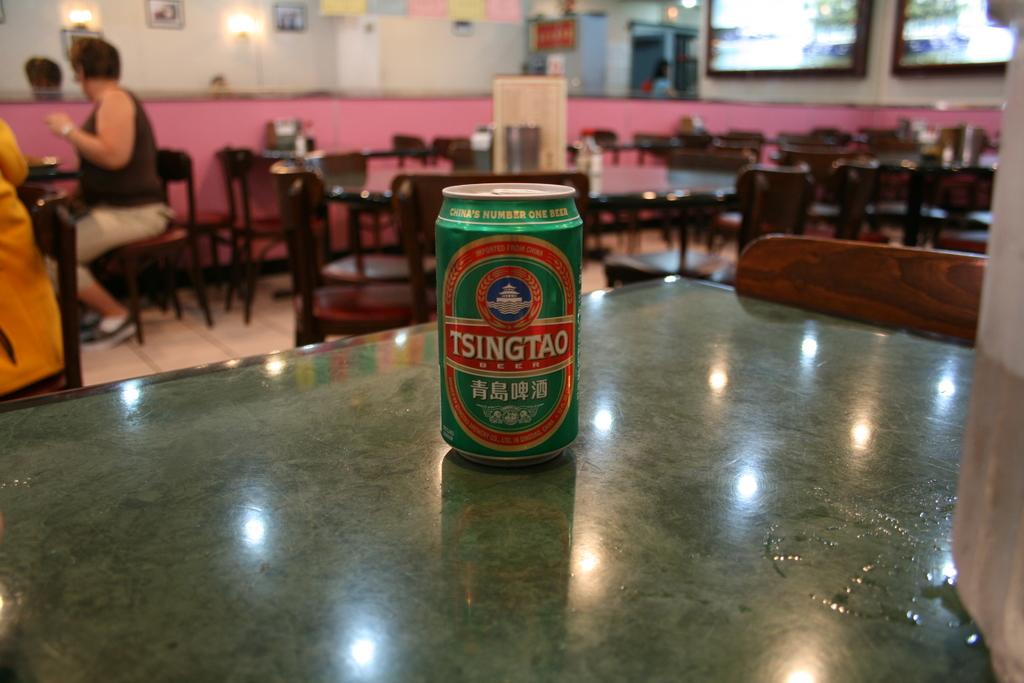What is the brand of this beer?
Keep it short and to the point. Tsingtao. 